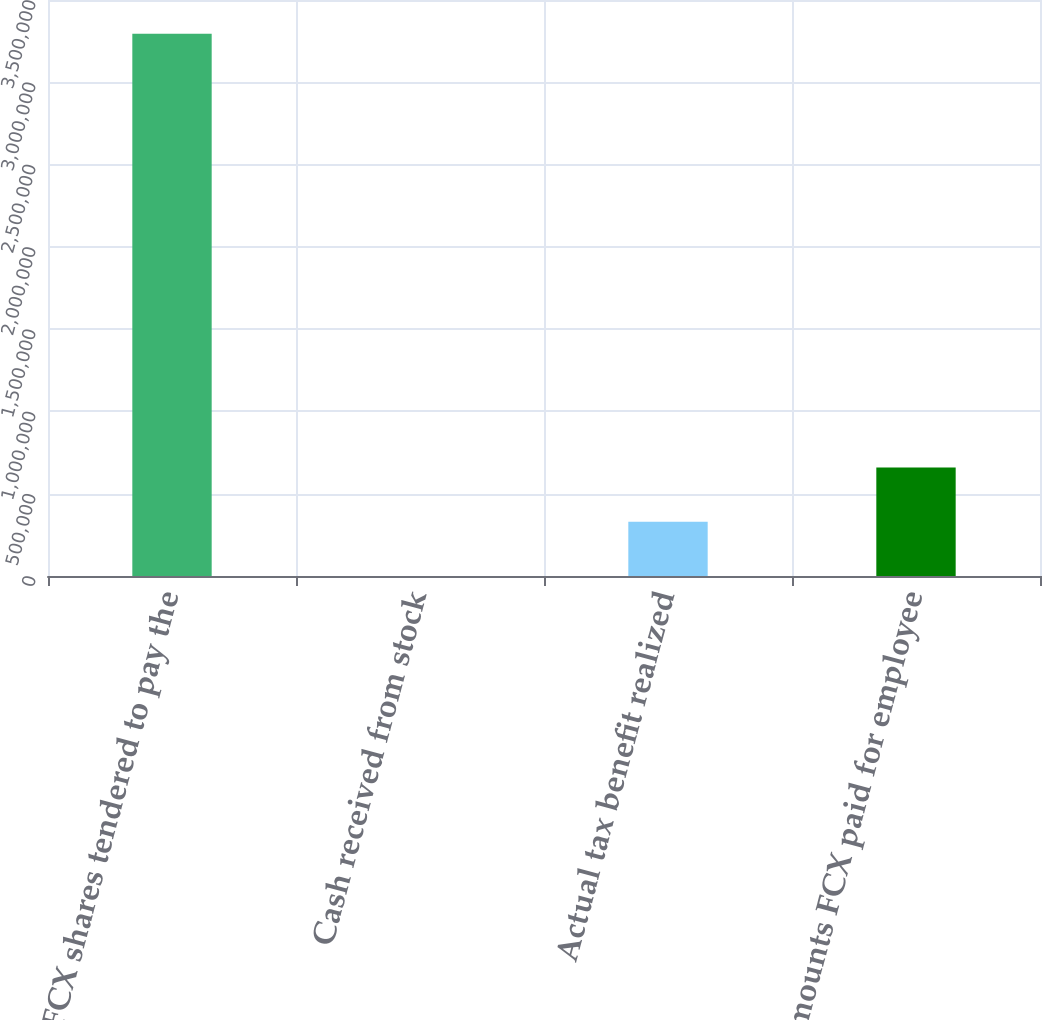Convert chart to OTSL. <chart><loc_0><loc_0><loc_500><loc_500><bar_chart><fcel>FCX shares tendered to pay the<fcel>Cash received from stock<fcel>Actual tax benefit realized<fcel>Amounts FCX paid for employee<nl><fcel>3.29462e+06<fcel>8<fcel>329470<fcel>658931<nl></chart> 